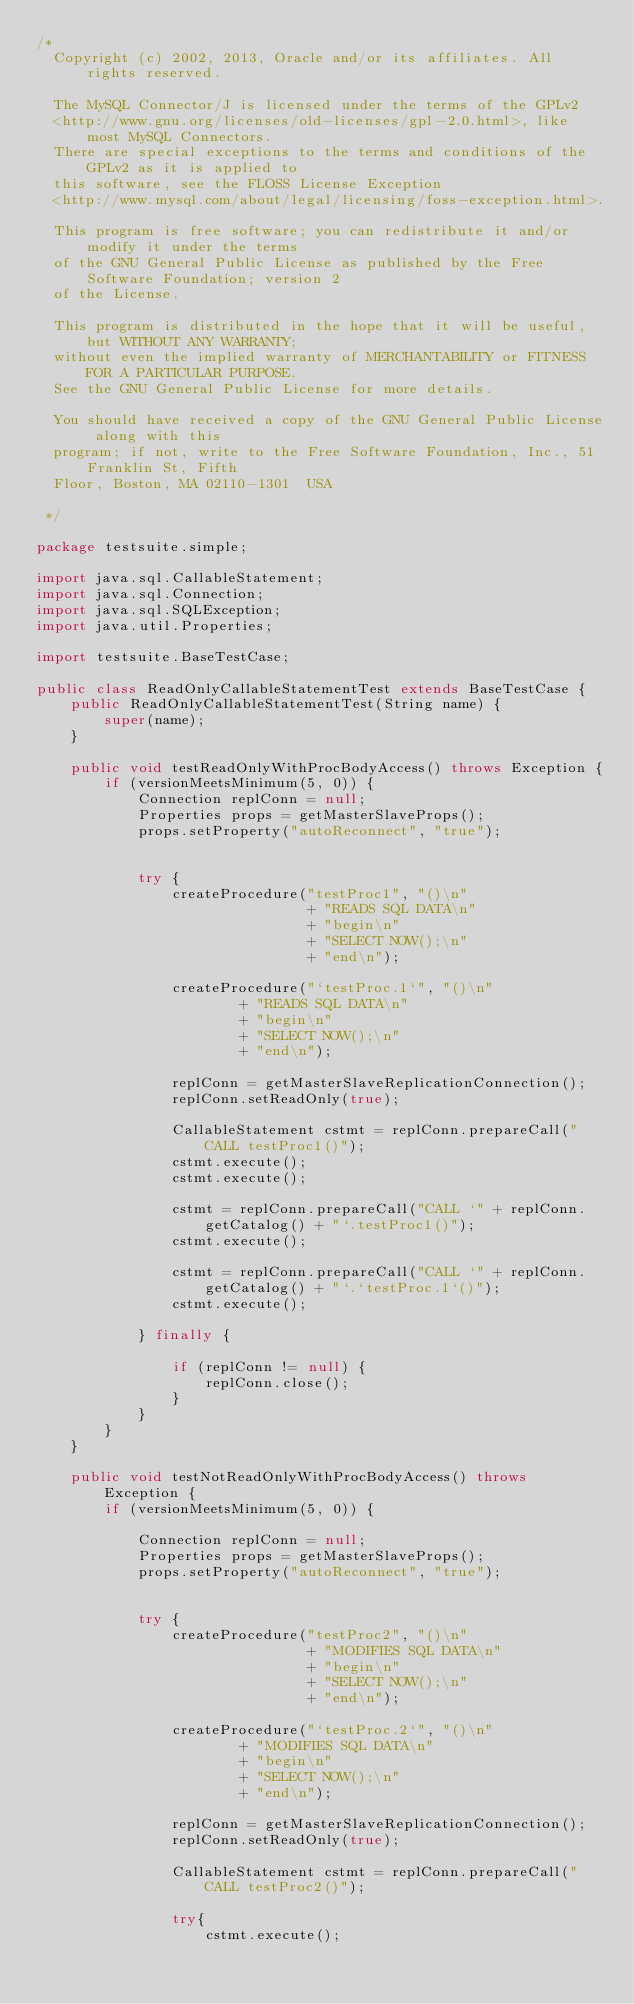<code> <loc_0><loc_0><loc_500><loc_500><_Java_>/*
  Copyright (c) 2002, 2013, Oracle and/or its affiliates. All rights reserved.

  The MySQL Connector/J is licensed under the terms of the GPLv2
  <http://www.gnu.org/licenses/old-licenses/gpl-2.0.html>, like most MySQL Connectors.
  There are special exceptions to the terms and conditions of the GPLv2 as it is applied to
  this software, see the FLOSS License Exception
  <http://www.mysql.com/about/legal/licensing/foss-exception.html>.

  This program is free software; you can redistribute it and/or modify it under the terms
  of the GNU General Public License as published by the Free Software Foundation; version 2
  of the License.

  This program is distributed in the hope that it will be useful, but WITHOUT ANY WARRANTY;
  without even the implied warranty of MERCHANTABILITY or FITNESS FOR A PARTICULAR PURPOSE.
  See the GNU General Public License for more details.

  You should have received a copy of the GNU General Public License along with this
  program; if not, write to the Free Software Foundation, Inc., 51 Franklin St, Fifth
  Floor, Boston, MA 02110-1301  USA
 
 */

package testsuite.simple;

import java.sql.CallableStatement;
import java.sql.Connection;
import java.sql.SQLException;
import java.util.Properties;

import testsuite.BaseTestCase;

public class ReadOnlyCallableStatementTest extends BaseTestCase {
	public ReadOnlyCallableStatementTest(String name) {
		super(name);
	}

	public void testReadOnlyWithProcBodyAccess() throws Exception {
		if (versionMeetsMinimum(5, 0)) {
			Connection replConn = null;
			Properties props = getMasterSlaveProps();
			props.setProperty("autoReconnect", "true");
	
			
			try {
				createProcedure("testProc1", "()\n"
								+ "READS SQL DATA\n"
								+ "begin\n"
								+ "SELECT NOW();\n"
								+ "end\n");

				createProcedure("`testProc.1`", "()\n"
						+ "READS SQL DATA\n"
						+ "begin\n"
						+ "SELECT NOW();\n"
						+ "end\n");
				
				replConn = getMasterSlaveReplicationConnection();
				replConn.setReadOnly(true);
				
				CallableStatement cstmt = replConn.prepareCall("CALL testProc1()");
				cstmt.execute();
				cstmt.execute();
				
				cstmt = replConn.prepareCall("CALL `" + replConn.getCatalog() + "`.testProc1()");
				cstmt.execute();
				
				cstmt = replConn.prepareCall("CALL `" + replConn.getCatalog() + "`.`testProc.1`()");
				cstmt.execute();
				
			} finally {
			
				if (replConn != null) {
					replConn.close();
				}
			}
		}
	}
	
	public void testNotReadOnlyWithProcBodyAccess() throws Exception {
		if (versionMeetsMinimum(5, 0)) {
			
			Connection replConn = null;
			Properties props = getMasterSlaveProps();
			props.setProperty("autoReconnect", "true");
		
			
			try {
				createProcedure("testProc2", "()\n"
								+ "MODIFIES SQL DATA\n"
								+ "begin\n"
								+ "SELECT NOW();\n"
								+ "end\n");

				createProcedure("`testProc.2`", "()\n"
						+ "MODIFIES SQL DATA\n"
						+ "begin\n"
						+ "SELECT NOW();\n"
						+ "end\n");
				
				replConn = getMasterSlaveReplicationConnection();
				replConn.setReadOnly(true);
				
				CallableStatement cstmt = replConn.prepareCall("CALL testProc2()");

				try{
					cstmt.execute();</code> 